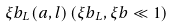<formula> <loc_0><loc_0><loc_500><loc_500>\xi b _ { L } ( a , l ) \, ( \xi b _ { L } , \xi b \ll 1 )</formula> 